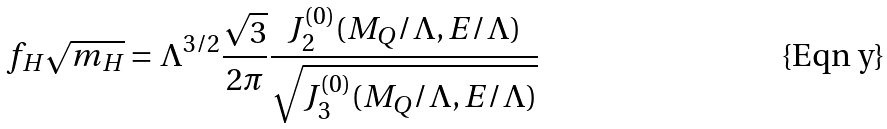Convert formula to latex. <formula><loc_0><loc_0><loc_500><loc_500>f _ { H } \sqrt { m _ { H } } = \Lambda ^ { 3 / 2 } \frac { \sqrt { 3 } } { 2 \pi } \frac { J _ { 2 } ^ { ( 0 ) } ( M _ { Q } / \Lambda , E / \Lambda ) } { \sqrt { J _ { 3 } ^ { ( 0 ) } ( M _ { Q } / \Lambda , E / \Lambda ) } }</formula> 